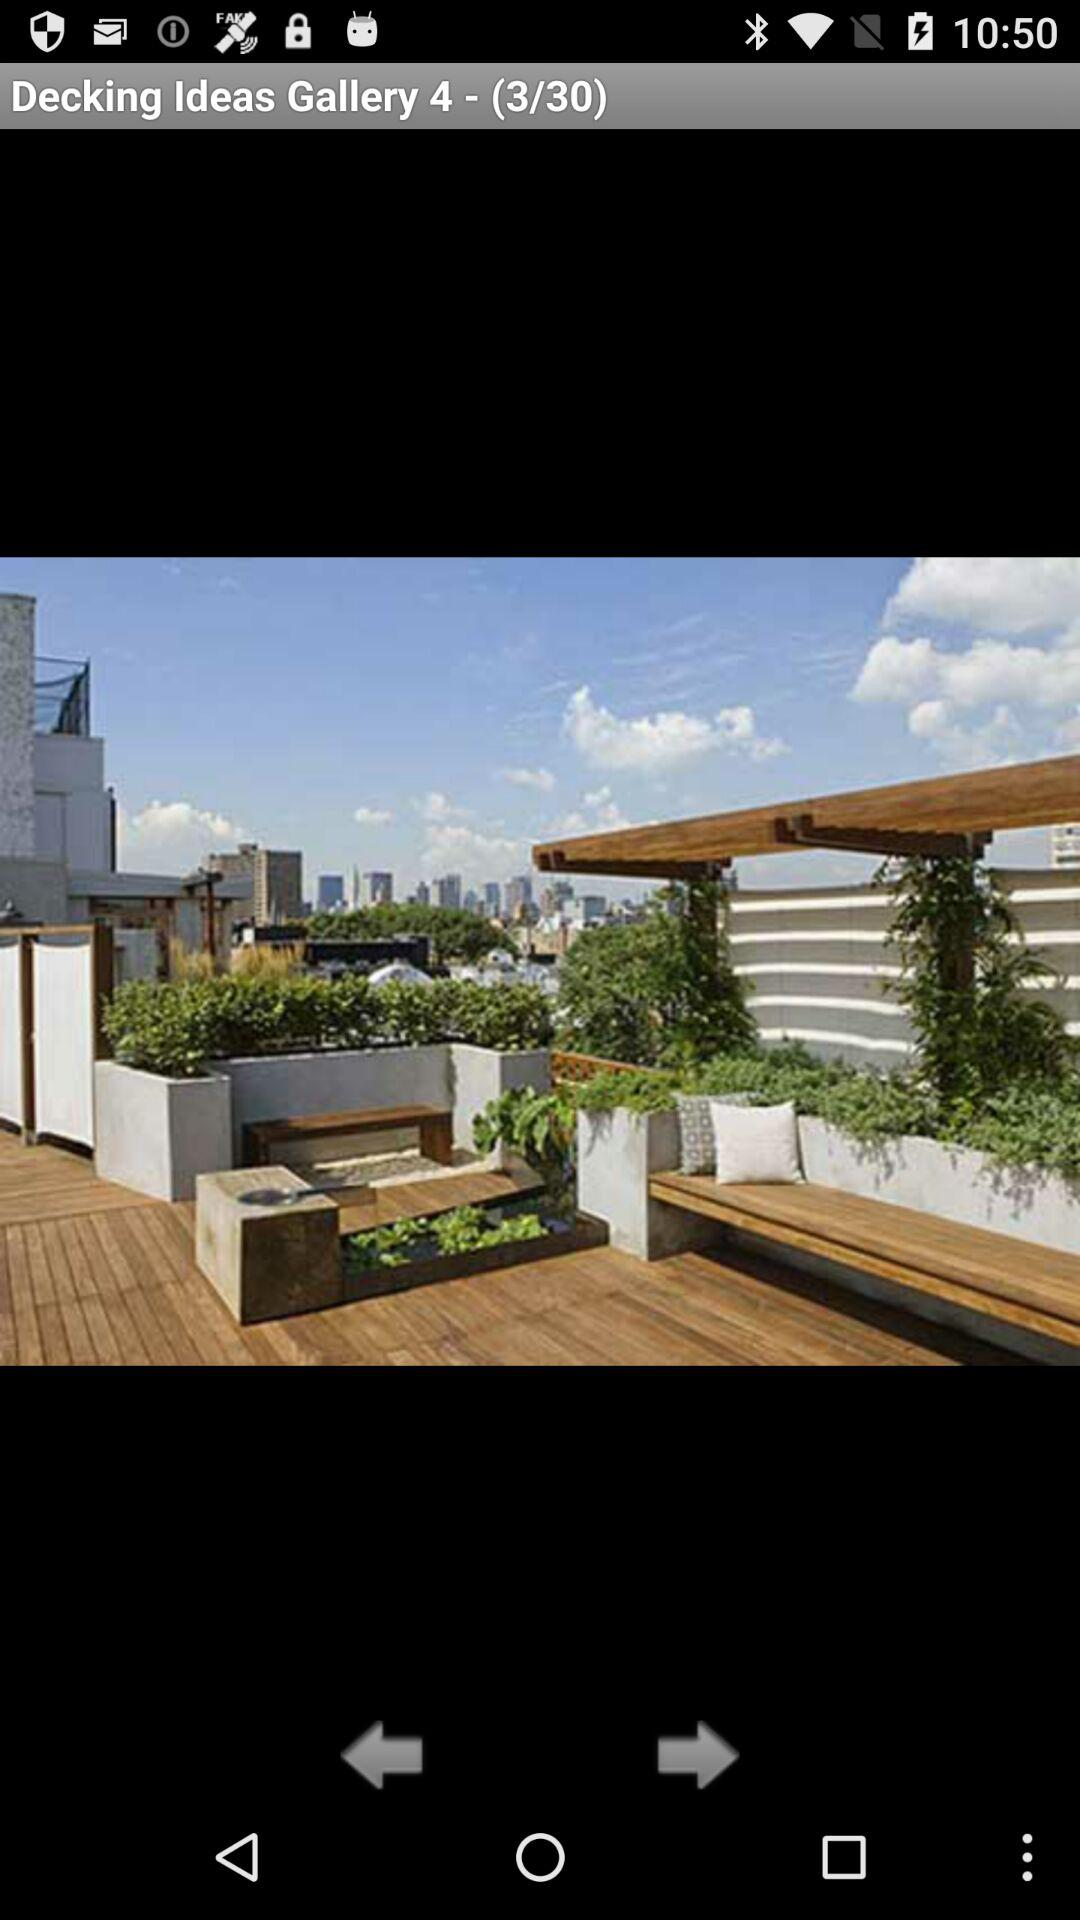At which image am I? You are at image 3. 